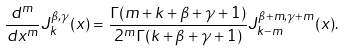<formula> <loc_0><loc_0><loc_500><loc_500>\frac { d ^ { m } } { d x ^ { m } } J _ { k } ^ { \beta , \gamma } ( x ) = \frac { \Gamma ( m + k + \beta + \gamma + 1 ) } { 2 ^ { m } \Gamma ( k + \beta + \gamma + 1 ) } J _ { k - m } ^ { \beta + m , \gamma + m } ( x ) .</formula> 